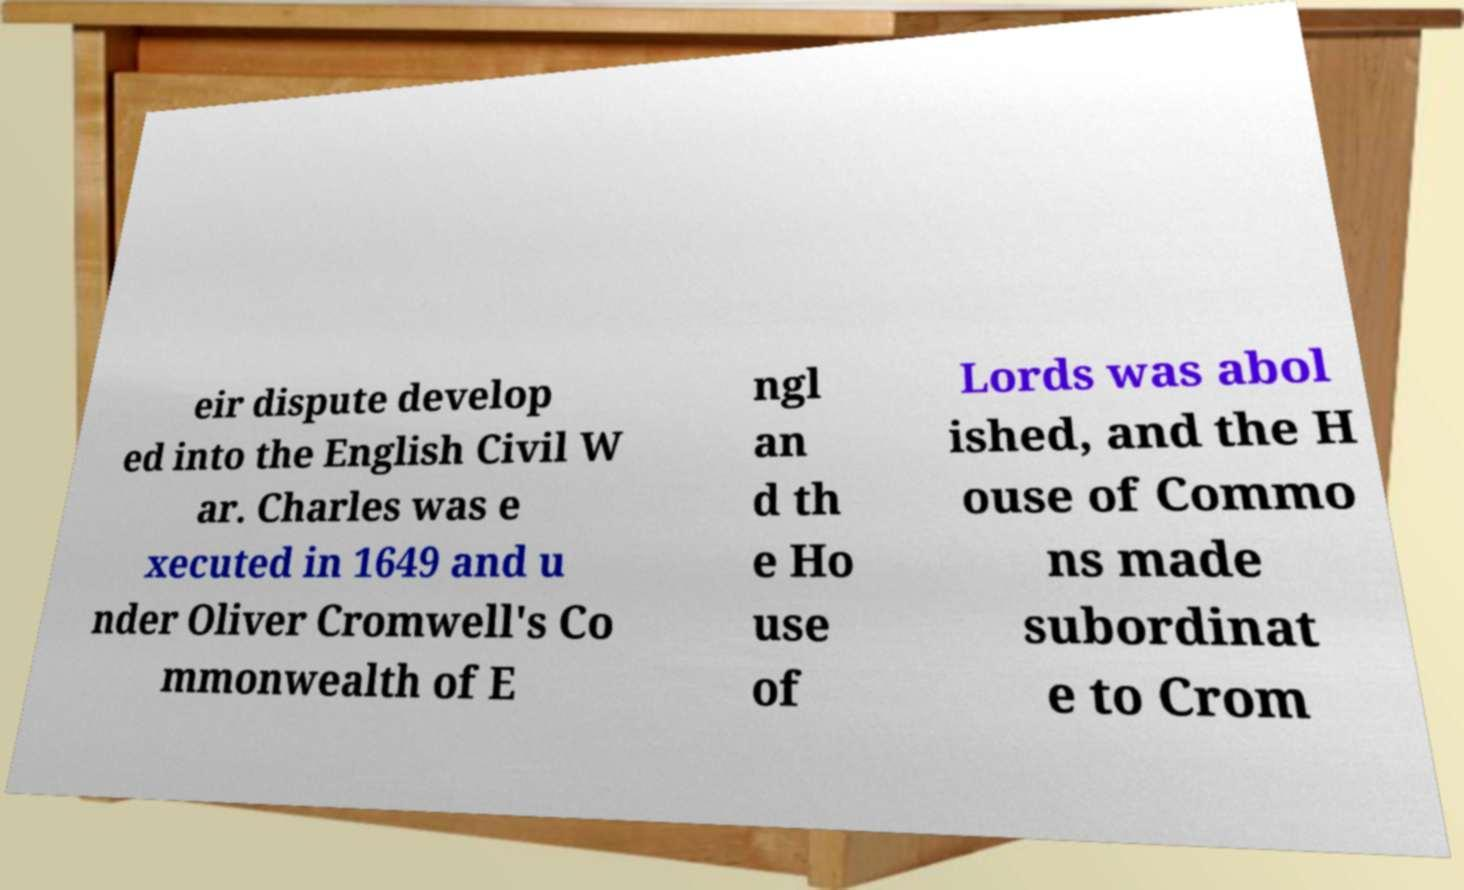Please identify and transcribe the text found in this image. eir dispute develop ed into the English Civil W ar. Charles was e xecuted in 1649 and u nder Oliver Cromwell's Co mmonwealth of E ngl an d th e Ho use of Lords was abol ished, and the H ouse of Commo ns made subordinat e to Crom 